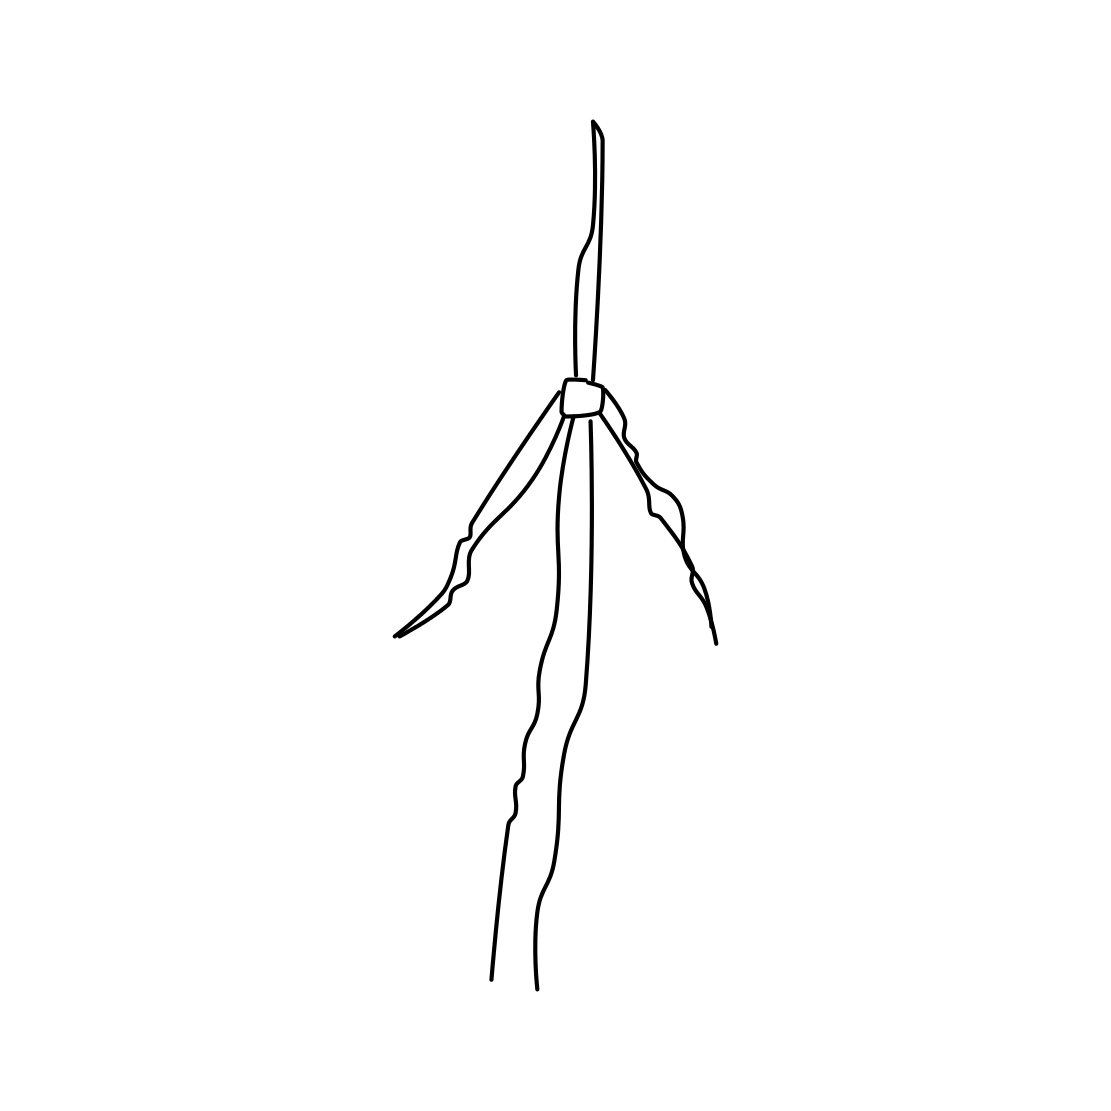What could the lines in the image represent if interpreted artistically? Artistically, the lines in the image might represent the concept of growth or reaching upward towards goals and aspirations. The central structure suggests stability, while the lines extending from it can symbolize extending one's reach or trying to connect with something beyond oneself. 